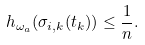Convert formula to latex. <formula><loc_0><loc_0><loc_500><loc_500>h _ { \omega _ { a } } ( \sigma _ { i , k } ( t _ { k } ) ) \leq \frac { 1 } { n } .</formula> 